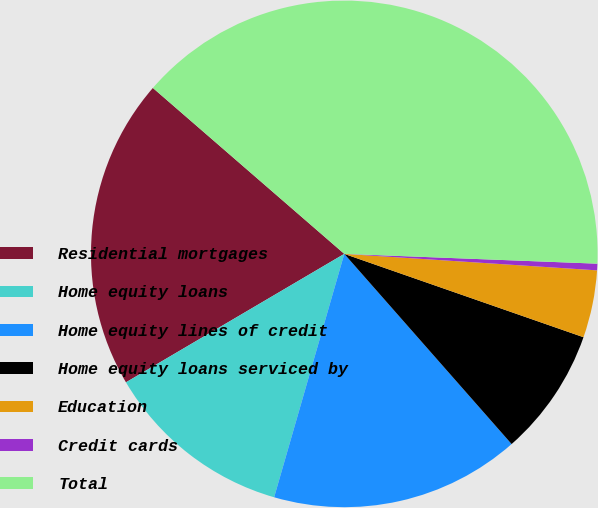Convert chart. <chart><loc_0><loc_0><loc_500><loc_500><pie_chart><fcel>Residential mortgages<fcel>Home equity loans<fcel>Home equity lines of credit<fcel>Home equity loans serviced by<fcel>Education<fcel>Credit cards<fcel>Total<nl><fcel>19.83%<fcel>12.07%<fcel>15.95%<fcel>8.18%<fcel>4.3%<fcel>0.42%<fcel>39.25%<nl></chart> 